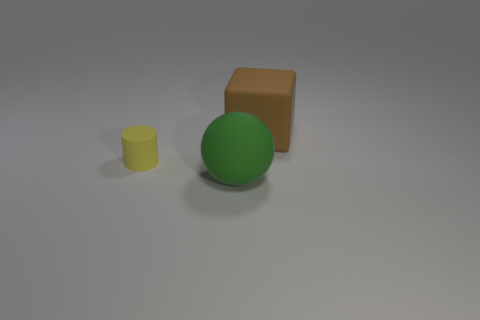Add 2 small objects. How many objects exist? 5 Subtract all cylinders. How many objects are left? 2 Subtract all objects. Subtract all tiny shiny things. How many objects are left? 0 Add 1 rubber objects. How many rubber objects are left? 4 Add 2 large things. How many large things exist? 4 Subtract 0 cyan cylinders. How many objects are left? 3 